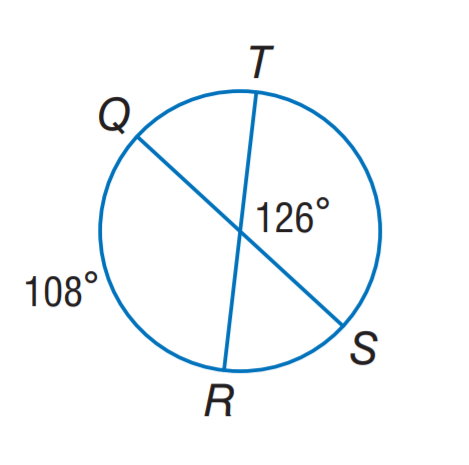Answer the mathemtical geometry problem and directly provide the correct option letter.
Question: Find m \widehat T S.
Choices: A: 108 B: 126 C: 132 D: 144 D 